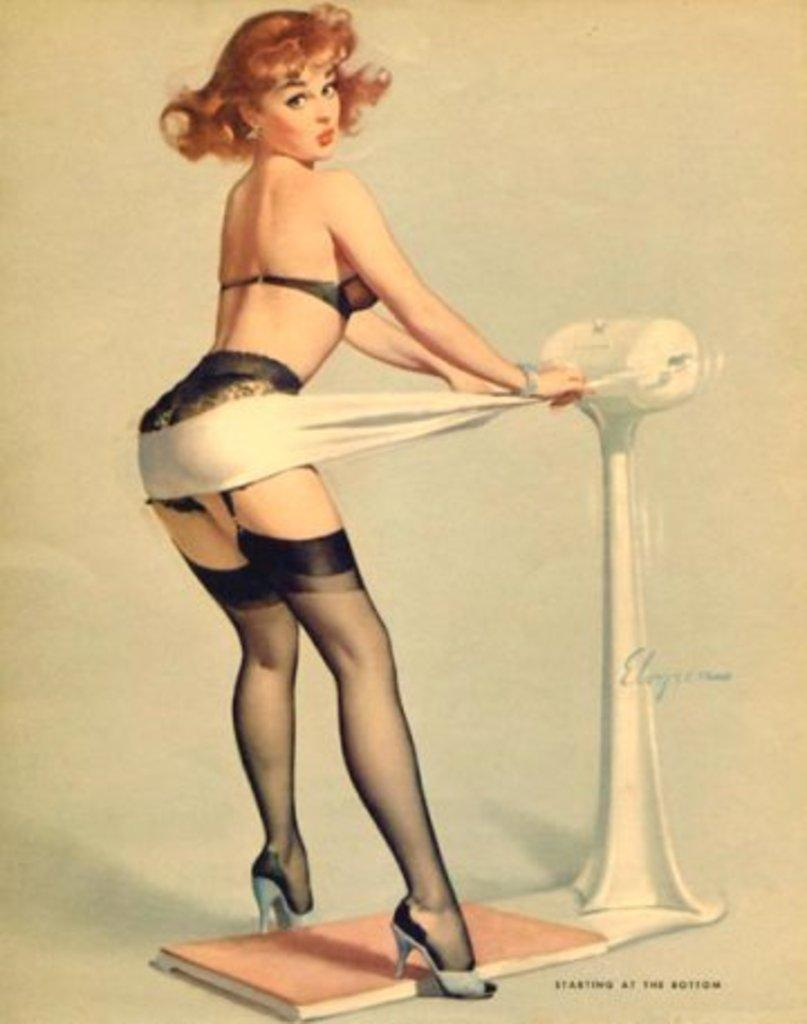What is the main subject of the image? There is a woman standing in the image. What can be seen on the right side of the image? There is an object on the right side of the image. What is located at the bottom of the image? There is a board at the bottom of the image. What color is the background of the image? The background of the image is white. What type of club is the woman holding in the image? There is no club present in the image; the woman is not holding any object. 